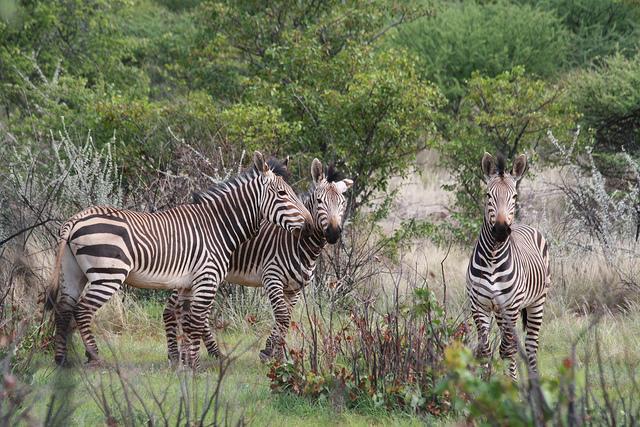How many zebras do you see?
Give a very brief answer. 3. How many giraffes are in this picture?
Give a very brief answer. 0. How many zebras are there?
Give a very brief answer. 3. 